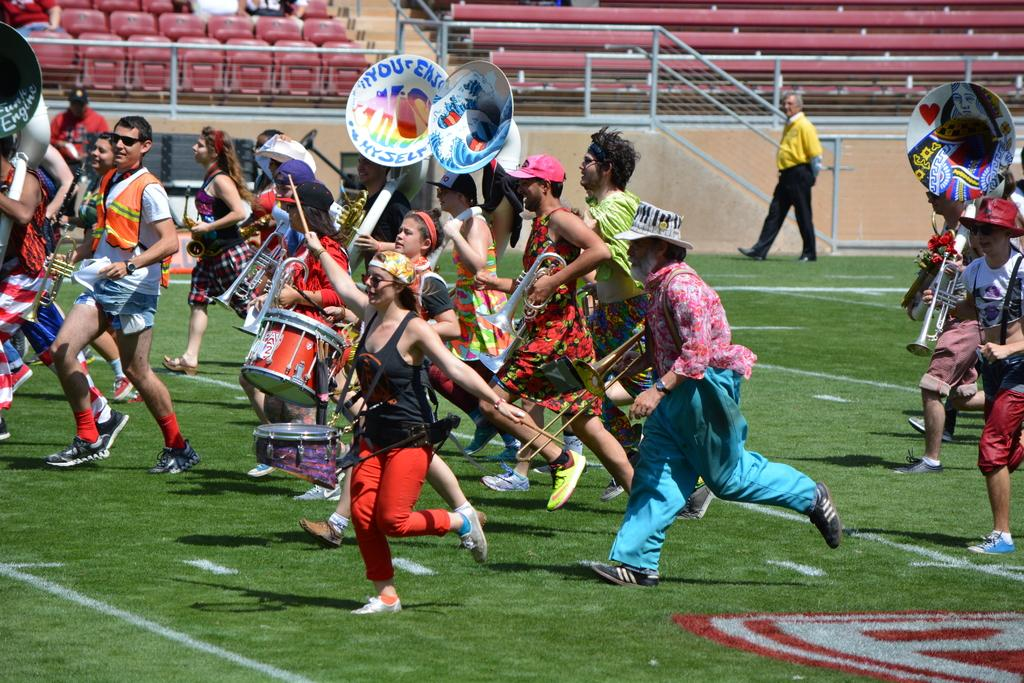How many people are in the image? There is a group of people in the image, but the exact number is not specified. What type of musical instrument can be seen in the image? There are musical drums and different types of musical instruments in the image. What is the ground surface like in the image? There is grass in the image, suggesting that the ground is covered with grass. What type of seating is available in the image? There are chairs in the image. What architectural feature is present in the image? There are stairs in the image. What type of barrier is present in the image? There is a fence in the image. Can you see a giraffe walking along the fence in the image? No, there is no giraffe present in the image. What type of line is drawn across the musical instruments in the image? There is no line drawn across the musical instruments in the image. 